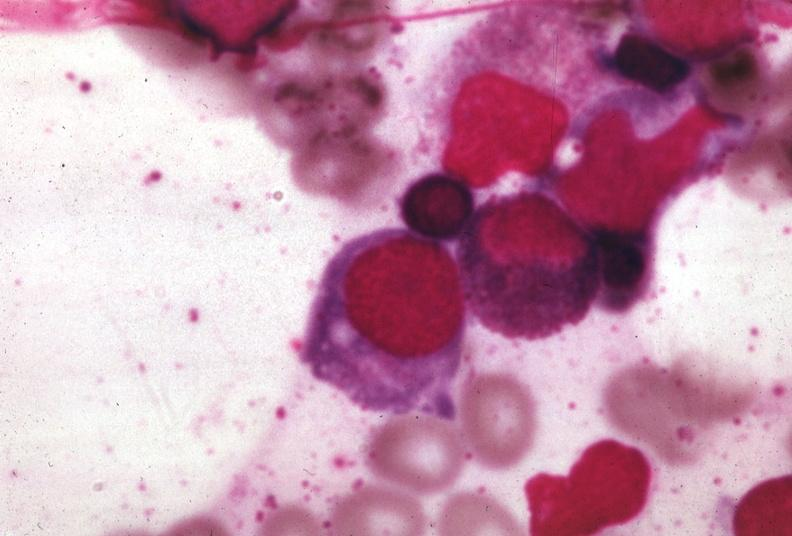s another fiber other frame present?
Answer the question using a single word or phrase. No 